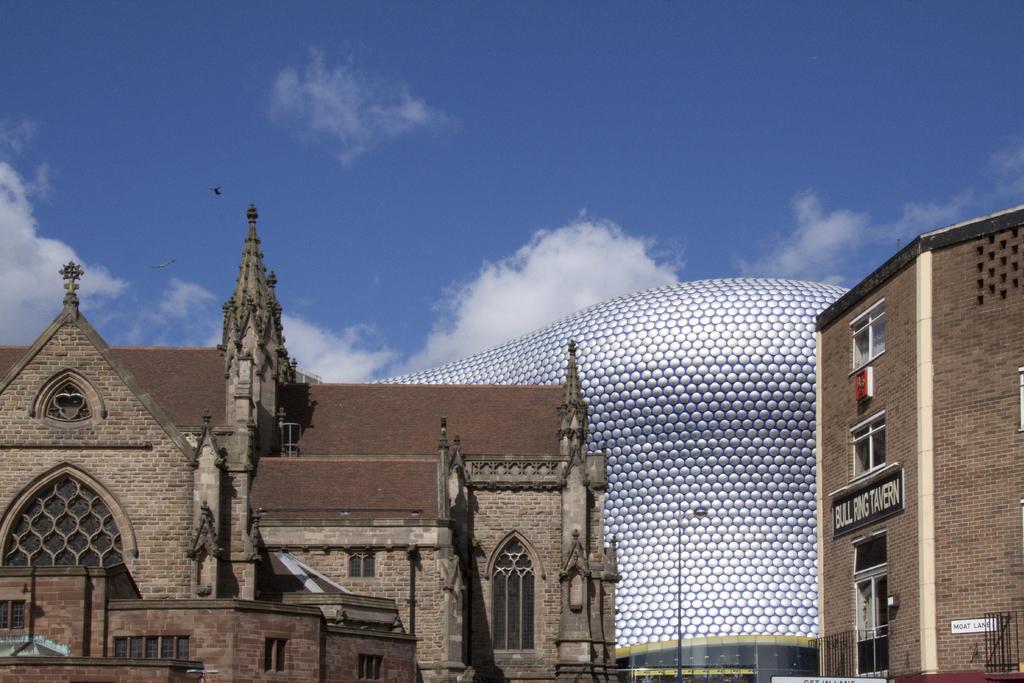How would you summarize this image in a sentence or two? There are buildings on the ground. In the background, there are clouds in the blue sky. 